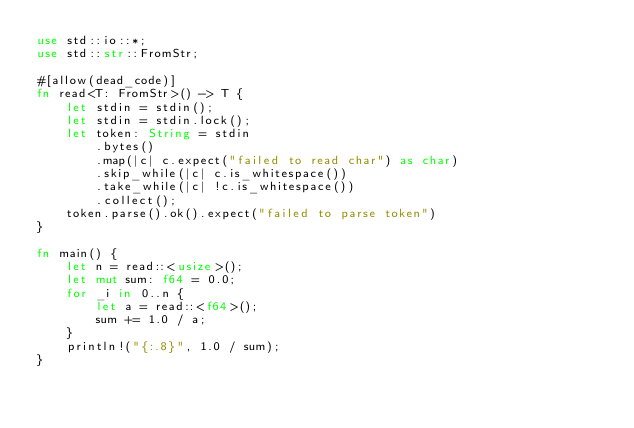<code> <loc_0><loc_0><loc_500><loc_500><_Rust_>use std::io::*;
use std::str::FromStr;

#[allow(dead_code)]
fn read<T: FromStr>() -> T {
    let stdin = stdin();
    let stdin = stdin.lock();
    let token: String = stdin
        .bytes()
        .map(|c| c.expect("failed to read char") as char)
        .skip_while(|c| c.is_whitespace())
        .take_while(|c| !c.is_whitespace())
        .collect();
    token.parse().ok().expect("failed to parse token")
}

fn main() {
    let n = read::<usize>();
    let mut sum: f64 = 0.0;
    for _i in 0..n {
        let a = read::<f64>();
        sum += 1.0 / a;
    }
    println!("{:.8}", 1.0 / sum);
}
</code> 